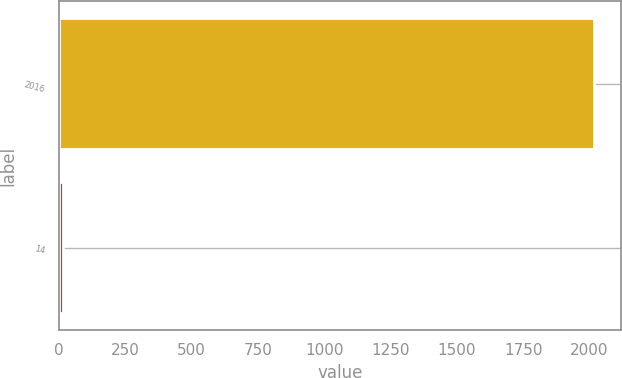<chart> <loc_0><loc_0><loc_500><loc_500><bar_chart><fcel>2016<fcel>14<nl><fcel>2017<fcel>14<nl></chart> 